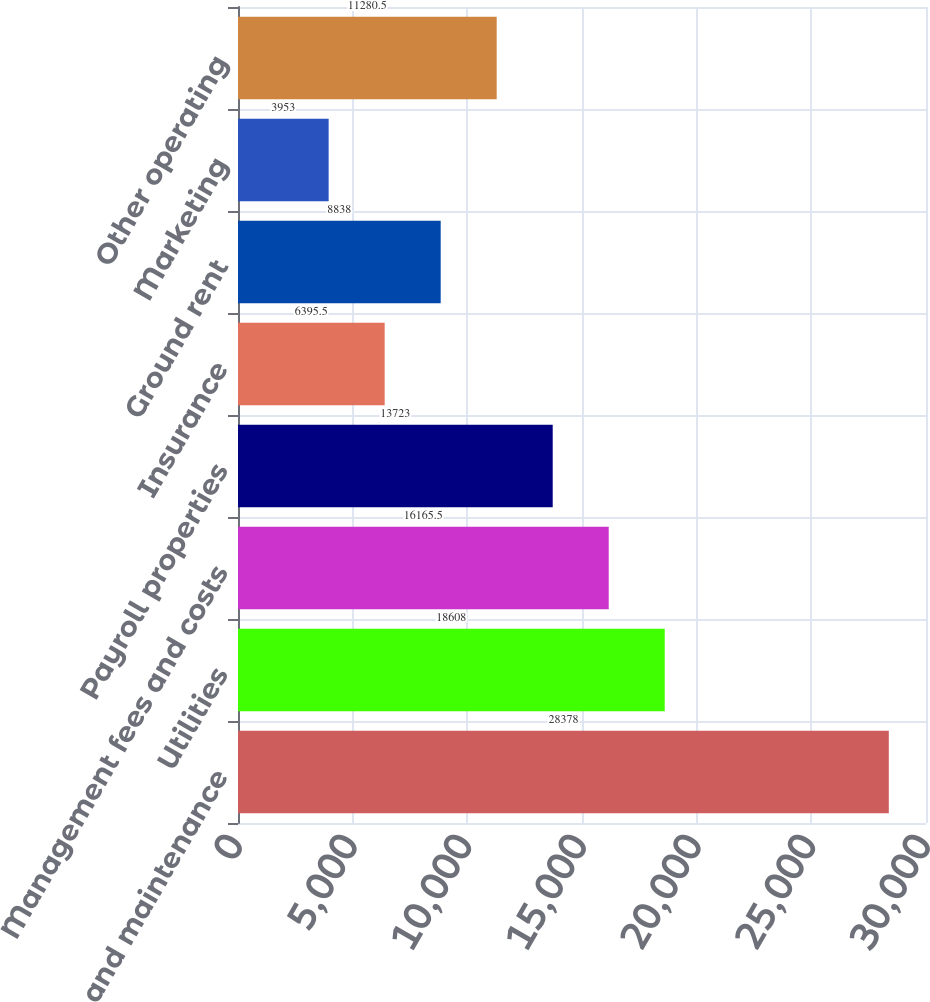<chart> <loc_0><loc_0><loc_500><loc_500><bar_chart><fcel>Repairs and maintenance<fcel>Utilities<fcel>Management fees and costs<fcel>Payroll properties<fcel>Insurance<fcel>Ground rent<fcel>Marketing<fcel>Other operating<nl><fcel>28378<fcel>18608<fcel>16165.5<fcel>13723<fcel>6395.5<fcel>8838<fcel>3953<fcel>11280.5<nl></chart> 